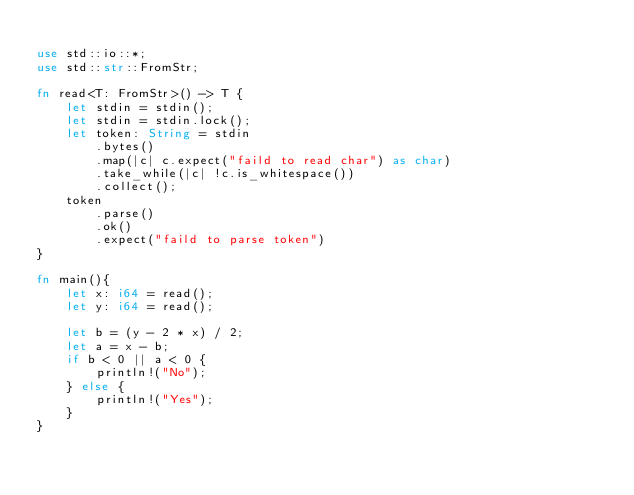<code> <loc_0><loc_0><loc_500><loc_500><_Rust_>
use std::io::*;
use std::str::FromStr;

fn read<T: FromStr>() -> T {
    let stdin = stdin();
    let stdin = stdin.lock();
    let token: String = stdin
        .bytes()
        .map(|c| c.expect("faild to read char") as char)
        .take_while(|c| !c.is_whitespace())
        .collect();
    token
        .parse()
        .ok()
        .expect("faild to parse token")
}

fn main(){
    let x: i64 = read();
    let y: i64 = read();

    let b = (y - 2 * x) / 2;
    let a = x - b;
    if b < 0 || a < 0 {
        println!("No");
    } else {
        println!("Yes");
    }
}
</code> 